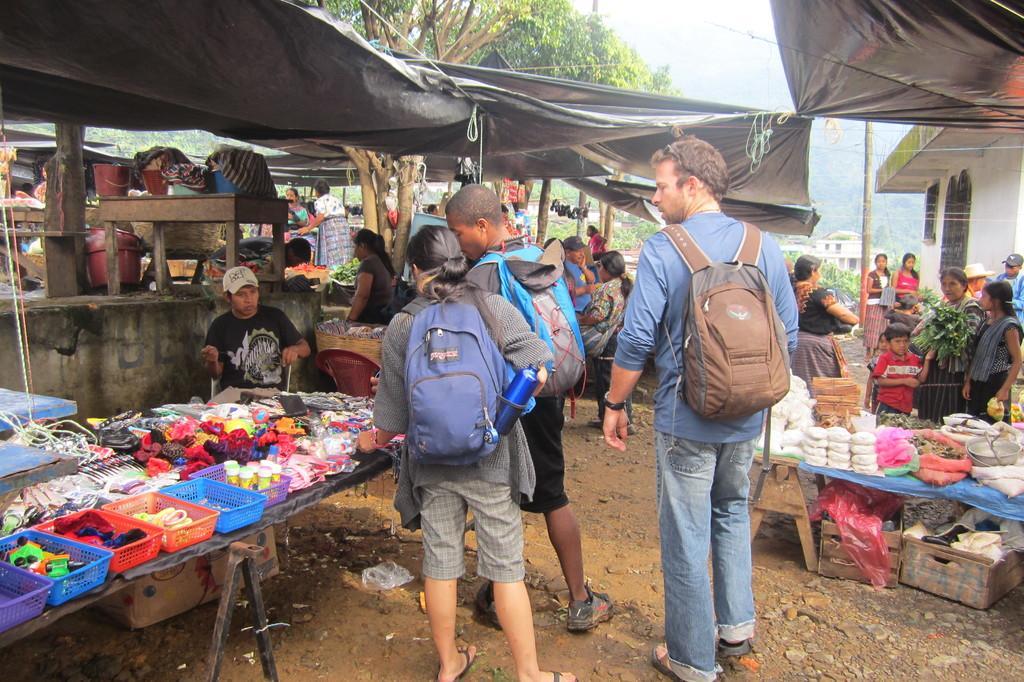Describe this image in one or two sentences. In the center of the image there are three persons wearing backpacks. To the right side of the image there is a stall and people standing. There is a house. To the left side of the image there is a stall and a person sitting on the chair. At the top of the image there is a black color cover. In the background of the image there are trees and sky. 